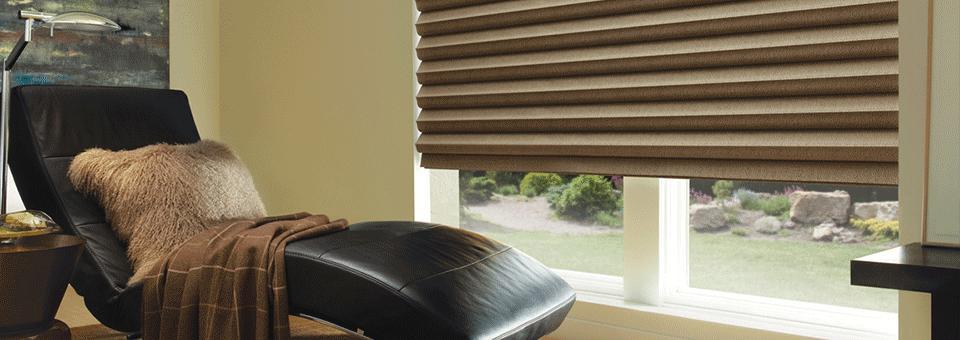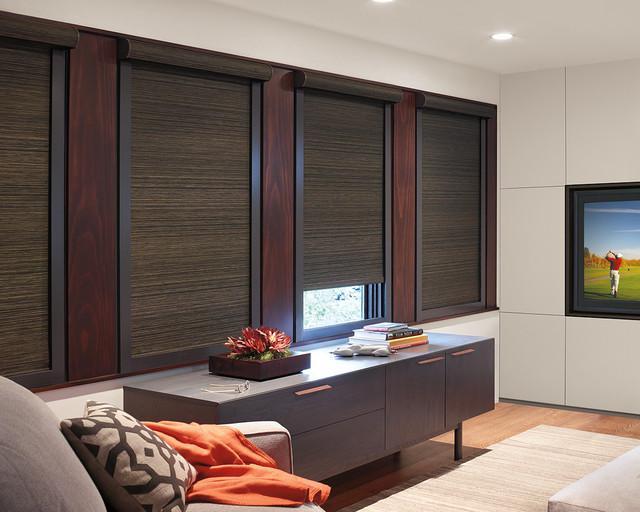The first image is the image on the left, the second image is the image on the right. Evaluate the accuracy of this statement regarding the images: "An image shows three neutral-colored shades in a row on a straight wall, each covering at least 2/3 of a pane-less window.". Is it true? Answer yes or no. No. 